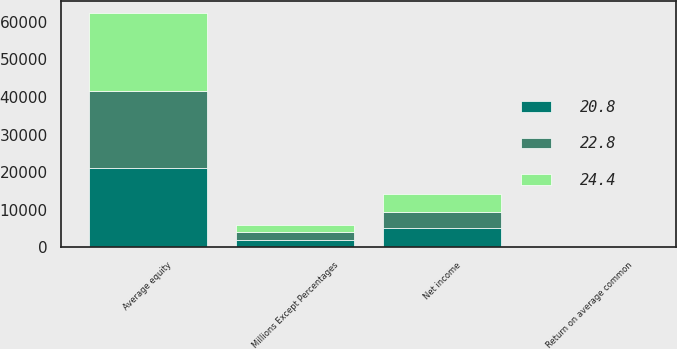Convert chart. <chart><loc_0><loc_0><loc_500><loc_500><stacked_bar_chart><ecel><fcel>Millions Except Percentages<fcel>Net income<fcel>Average equity<fcel>Return on average common<nl><fcel>22.8<fcel>2016<fcel>4233<fcel>20317<fcel>20.8<nl><fcel>24.4<fcel>2015<fcel>4772<fcel>20946<fcel>22.8<nl><fcel>20.8<fcel>2014<fcel>5180<fcel>21207<fcel>24.4<nl></chart> 